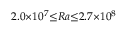Convert formula to latex. <formula><loc_0><loc_0><loc_500><loc_500>2 . 0 { \times } 1 0 ^ { 7 } { \leq } R a { \leq } 2 . 7 { \times } 1 0 ^ { 8 }</formula> 